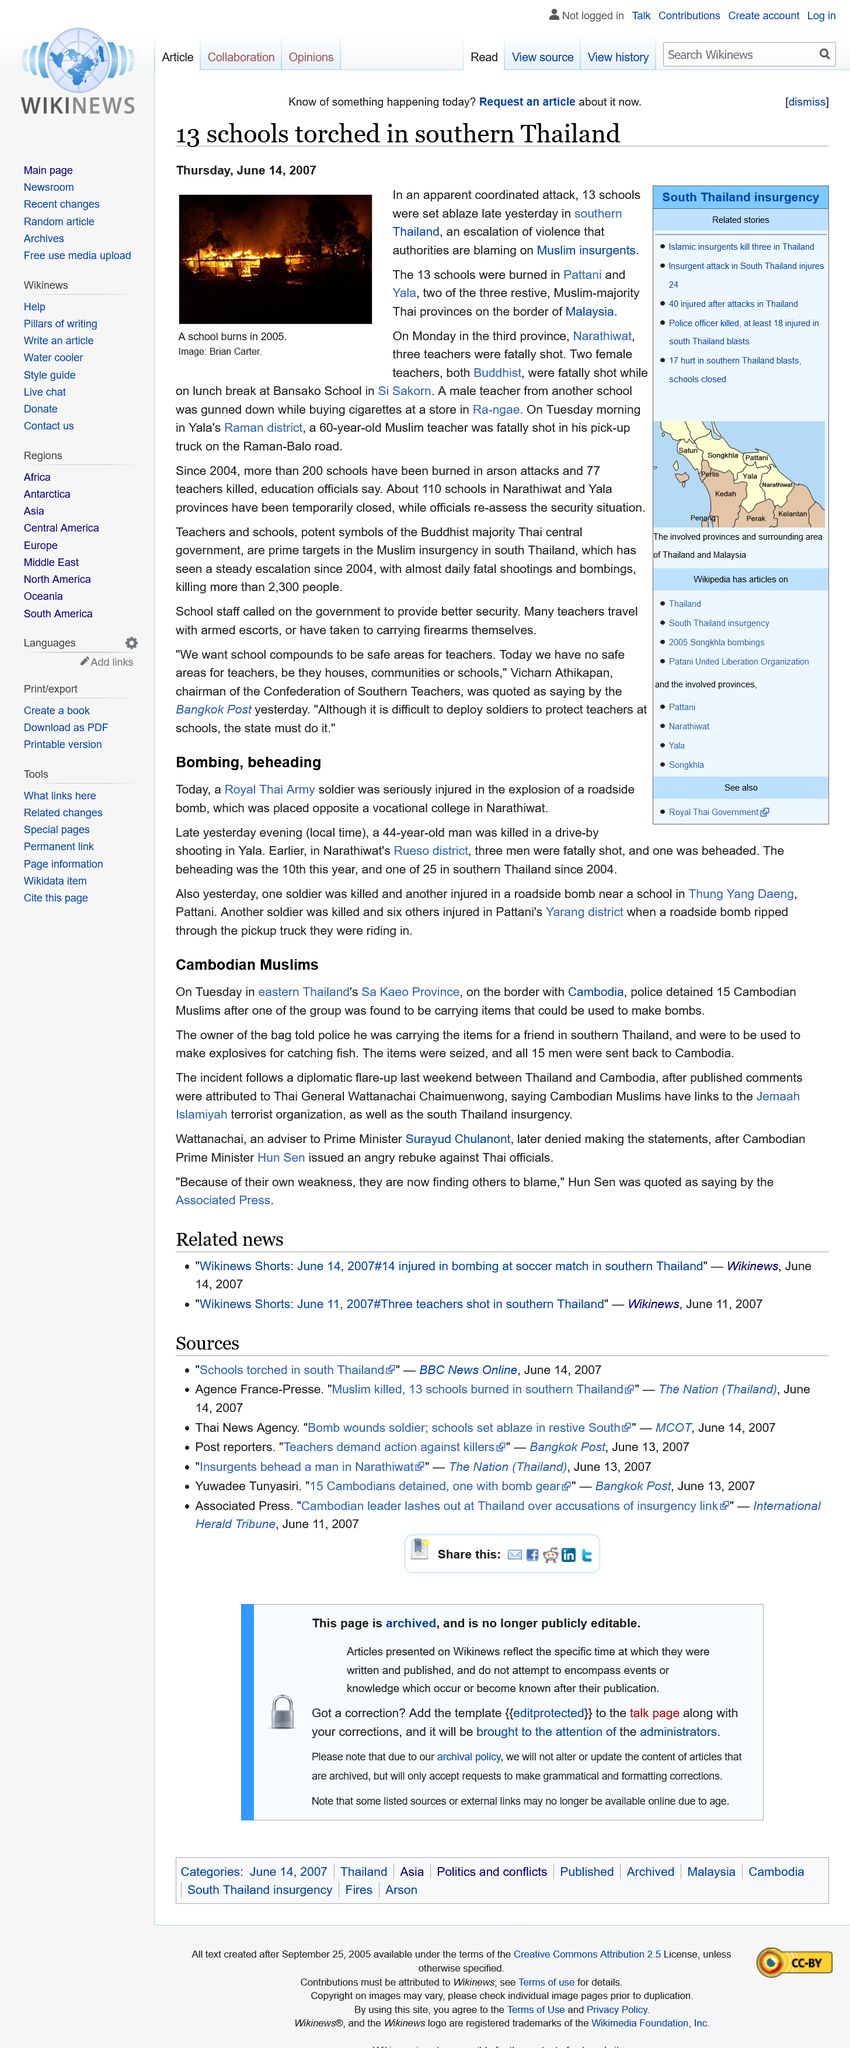Indicate a few pertinent items in this graphic. On Raman-Balo Road, a 60-year-old Muslim teacher was fatally shot in his pick-up truck. The image depicts a school that is on fire. This article mentions that 13 schools were set on fire. 